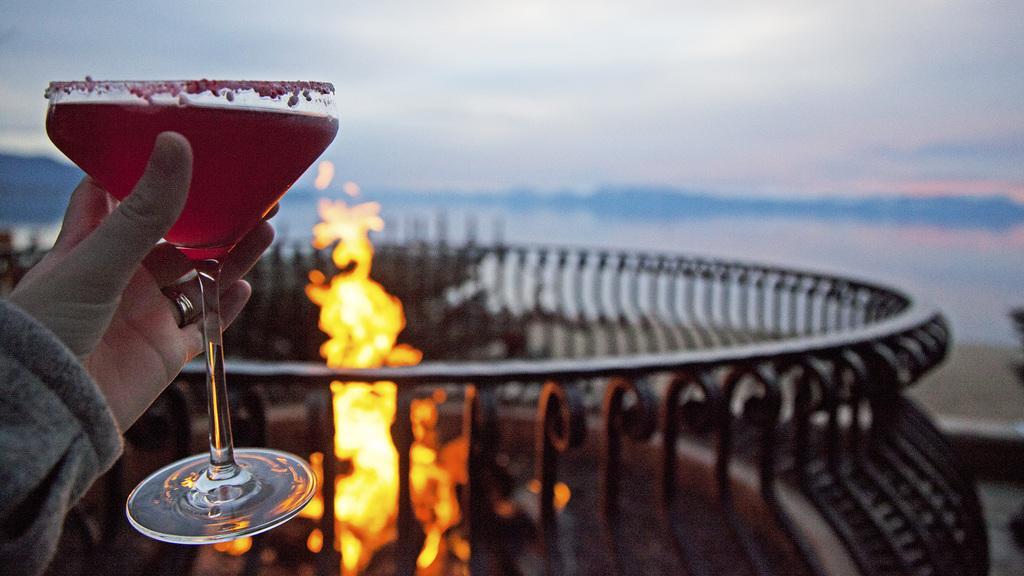In one or two sentences, can you explain what this image depicts? In the picture there is some drink in a glass held in a person's hand and in the background there is fire and around the fire there is fence. 